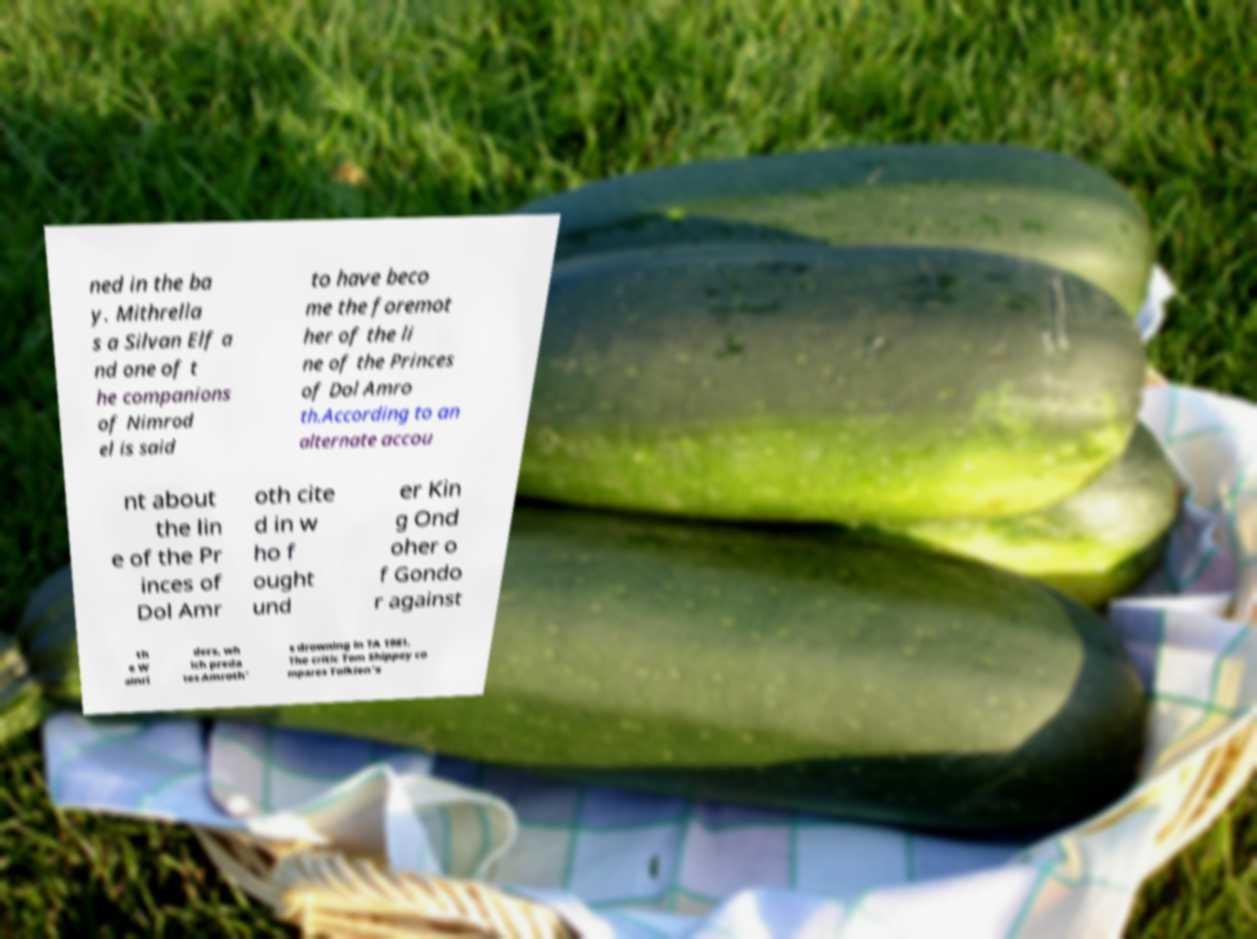For documentation purposes, I need the text within this image transcribed. Could you provide that? ned in the ba y. Mithrella s a Silvan Elf a nd one of t he companions of Nimrod el is said to have beco me the foremot her of the li ne of the Princes of Dol Amro th.According to an alternate accou nt about the lin e of the Pr inces of Dol Amr oth cite d in w ho f ought und er Kin g Ond oher o f Gondo r against th e W ainri ders, wh ich preda tes Amroth' s drowning in TA 1981. The critic Tom Shippey co mpares Tolkien's 